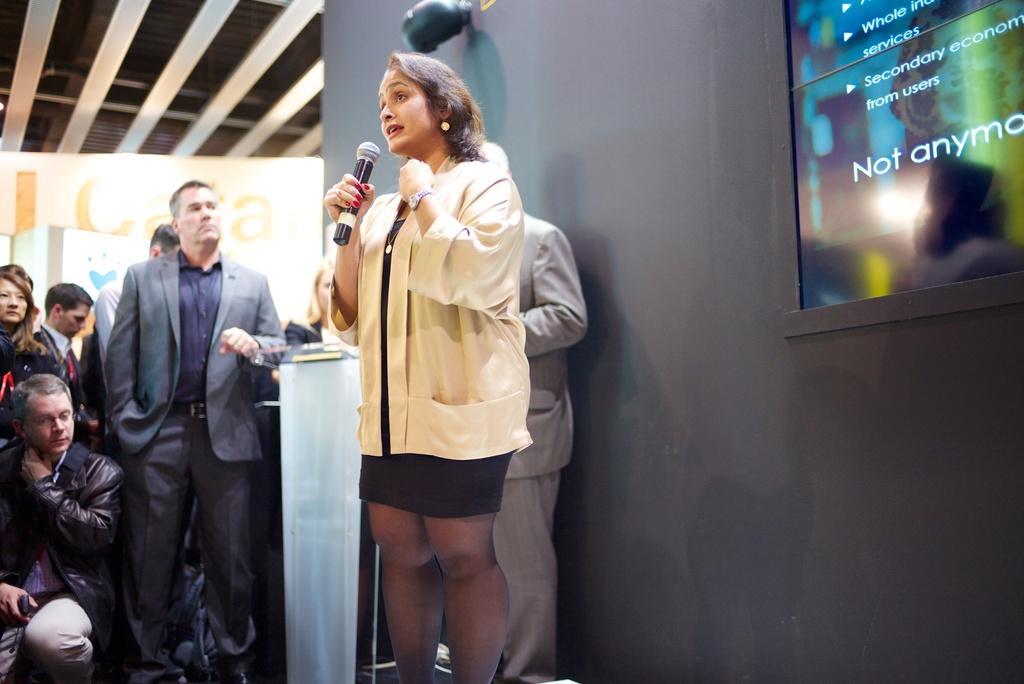Could you give a brief overview of what you see in this image? As we can see in the image there is a wall, few people here and there and the woman in the front is wearing white color jacket and holding a mic. 